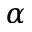<formula> <loc_0><loc_0><loc_500><loc_500>\alpha</formula> 